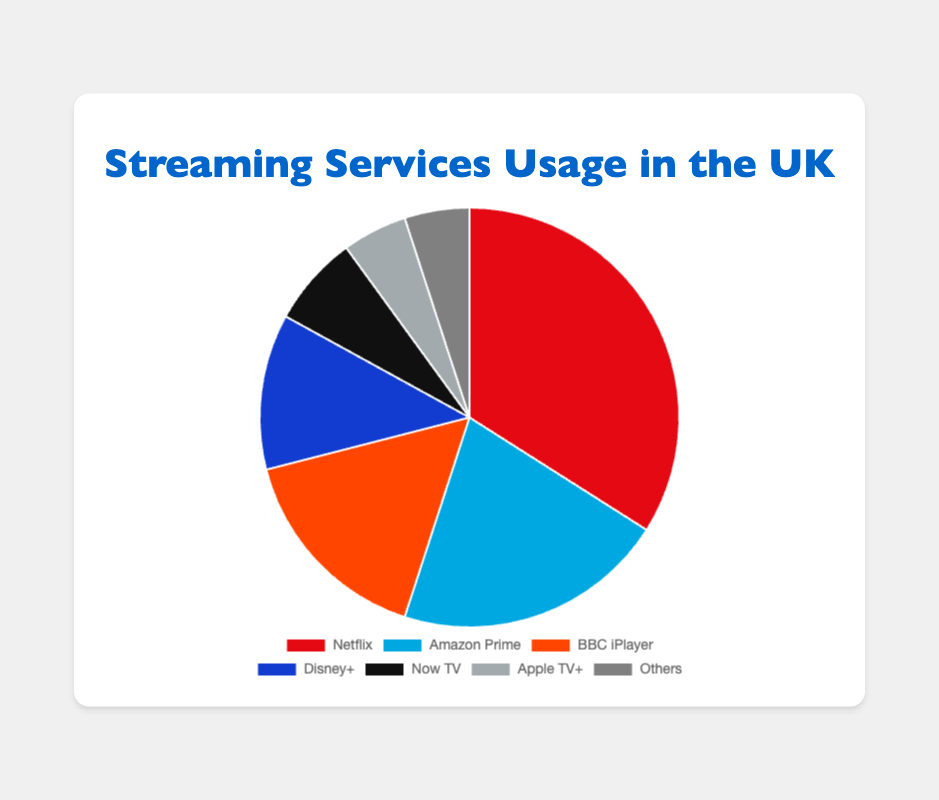What is the total usage proportion of BBC iPlayer and Disney+ combined? To find the combined usage proportion of BBC iPlayer and Disney+, add their individual proportions. BBC iPlayer has a proportion of 16% and Disney+ has 12%. 16 + 12 = 28
Answer: 28 Which service has the smallest proportion of usage? The smallest proportion of usage is indicated by the service with the lowest percentage. Both Apple TV+ and 'Others' have the smallest proportions, each at 5%.
Answer: Apple TV+ and 'Others' What is the difference in usage proportion between Netflix and Amazon Prime? To determine the difference, subtract the usage proportion of Amazon Prime from that of Netflix. Netflix has 34% and Amazon Prime has 21%. 34 - 21 = 13
Answer: 13 Which service has a higher usage proportion, Now TV or BBC iPlayer, and by how much? Compare the usage proportions of Now TV and BBC iPlayer. Now TV has 7% and BBC iPlayer has 16%. To find the difference, subtract Now TV's proportion from BBC iPlayer's. 16 - 7 = 9
Answer: BBC iPlayer by 9 What is the combined proportion of all services other than Netflix? To find the combined proportion, add the proportions of all services except Netflix. Sum of Amazon Prime, BBC iPlayer, Disney+, Now TV, Apple TV+, and 'Others' is 21 + 16 + 12 + 7 + 5 + 5 = 66
Answer: 66 If the total usage is split equally between Netflix, Amazon Prime, and BBC iPlayer, what would each service's proportion be? To find the proportion if the total usage is equally split, divide 100% by 3. 100 / 3 ≈ 33.33
Answer: 33.33 Among all the services, which one has a medium-ranking usage proportion and what is it? Arrange the proportions in ascending order: Apple TV+ (5), Others (5), Now TV (7), Disney+ (12), BBC iPlayer (16), Amazon Prime (21), Netflix (34). The median is Disney+ with 12%
Answer: Disney+ with 12 How much more popular is Disney+ compared to Apple TV+? Subtract the usage proportion of Apple TV+ from Disney+. Disney+ has 12% and Apple TV+ has 5%. 12 - 5 = 7
Answer: 7 What proportion of usage does the service with the second-highest usage have? The second-highest usage proportion is seen in Amazon Prime with 21%
Answer: 21 